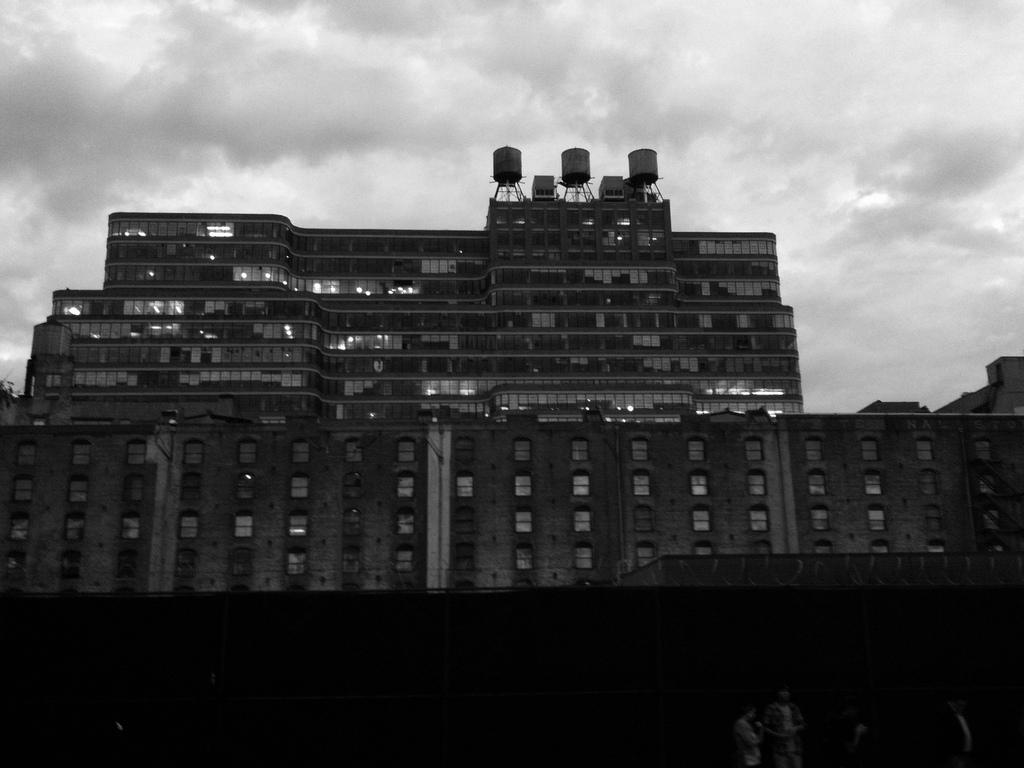Where was the image taken? The image was taken outdoors. What is the color scheme of the image? The image is black and white. What can be seen in the background of the image? There is sky visible in the image, and clouds are present in the sky. What is the main subject in the middle of the image? There is a building in the middle of the image. What type of wool is being used to knit the thing in the image? There is no wool or knitting activity present in the image. 